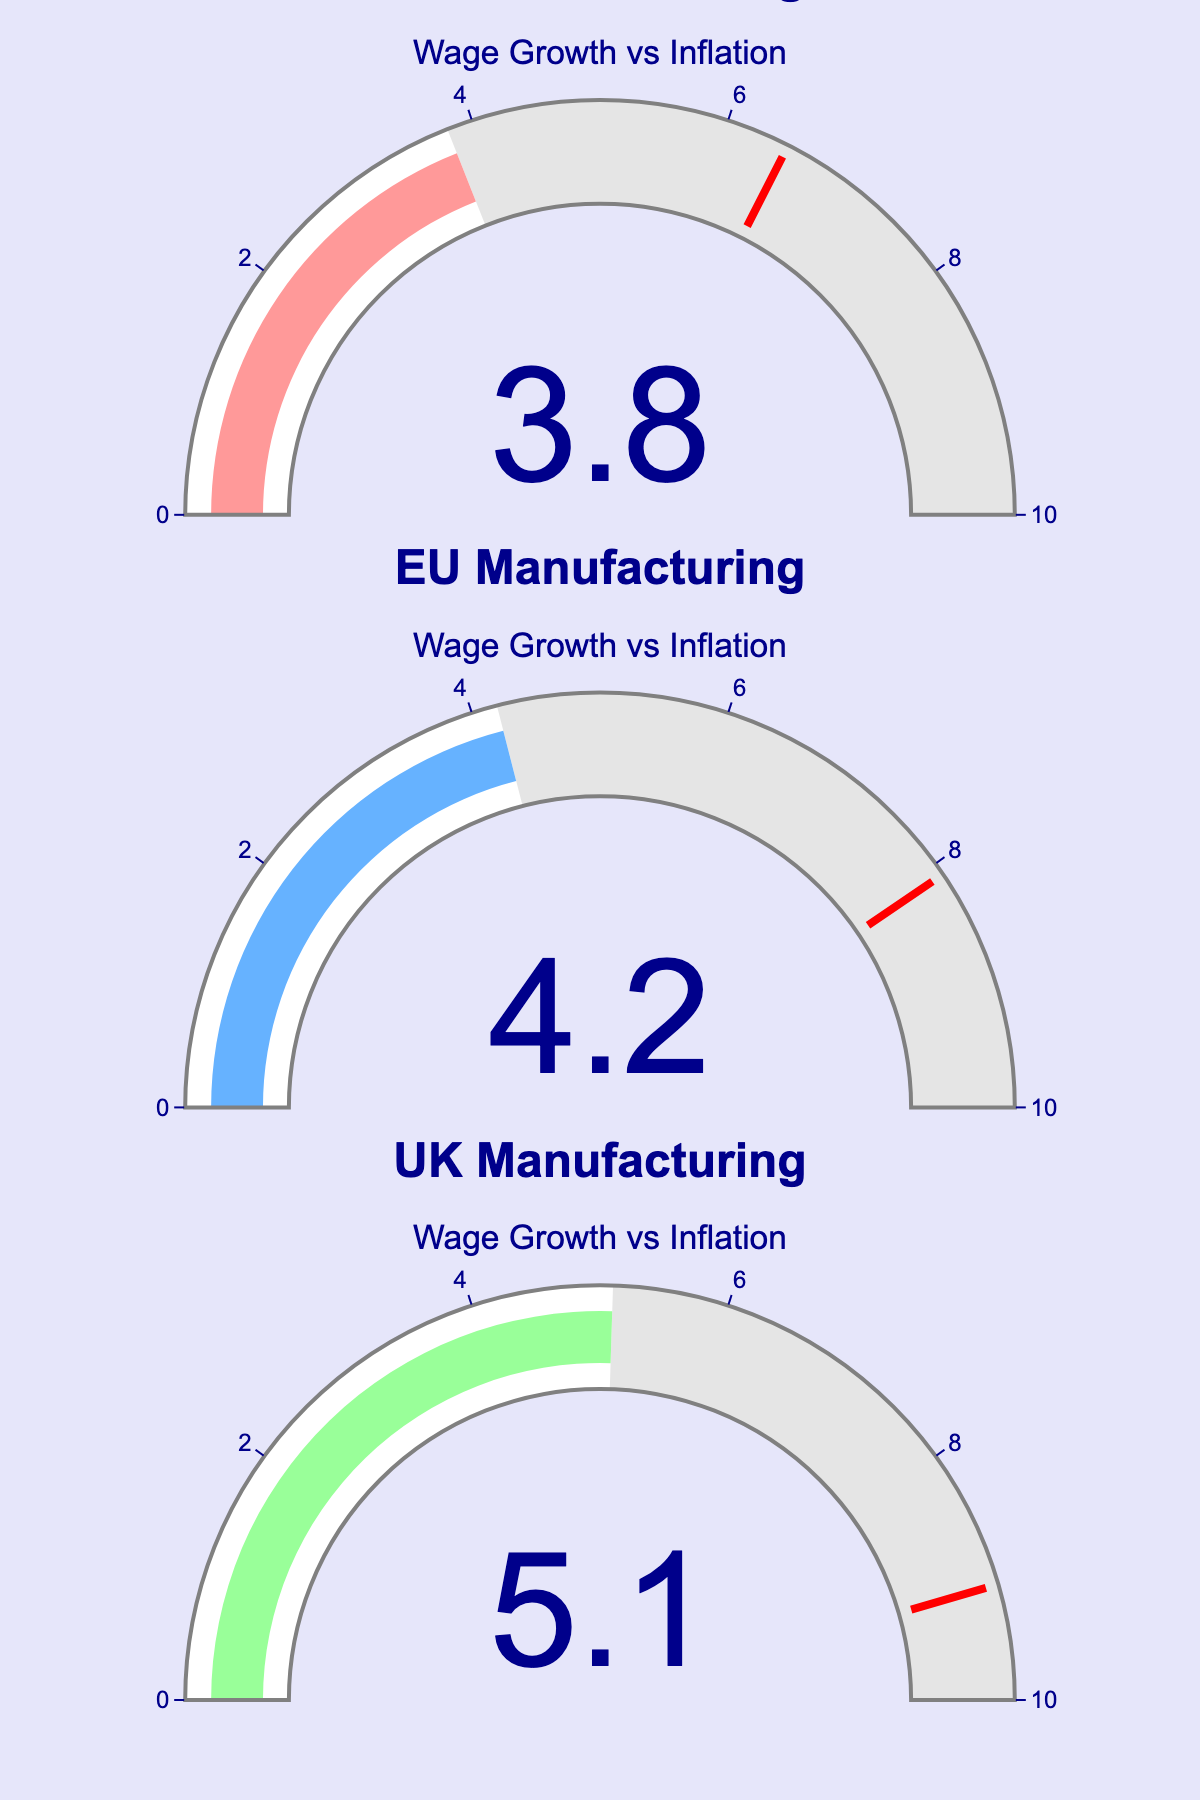What is the wage growth rate for US manufacturing in 2022? The gauge for the US manufacturing wage growth shows a value of 3.8.
Answer: 3.8 How does the inflation rate in the US compare to the manufacturing wage growth rate in 2022? The inflation rate for the US is indicated at 6.5, which is higher than the wage growth rate of 3.8.
Answer: Higher Which region has the highest manufacturing wage growth rate in 2022? The gauge for the EU manufacturing wage growth shows the highest value of 4.2, compared to the US (3.8) and the UK (5.1).
Answer: UK What is the difference between the wage growth rate and the inflation rate for the UK? The wage growth rate for the UK is 5.1 and the inflation rate is 9.1. The difference is calculated as 9.1 - 5.1 = 4.0.
Answer: 4.0 Among the US, EU, and the UK, which region has the smallest gap between wage growth and inflation in 2022? The differences between wage growth and inflation are: US (6.5 - 3.8 = 2.7), EU (8.1 - 4.2 = 3.9), and UK (9.1 - 5.1 = 4.0). The smallest gap is 2.7 (US).
Answer: US How much higher is the EU inflation rate compared to its manufacturing wage growth rate? The EU inflation rate is 8.1 while the manufacturing wage growth rate is 4.2. The difference is 8.1 - 4.2 = 3.9.
Answer: 3.9 Is the wage growth rate in the UK closer to its inflation rate compared to the US? The difference between wage growth and inflation in the UK is 4.0 (9.1 - 5.1) and in the US is 2.7 (6.5 - 3.8). Since 4.0 > 2.7, the wage growth rate in the UK is not closer to its inflation rate compared to the US.
Answer: No What overall trend can be observed about wage growth compared to inflation in all three regions? In all three regions, the inflation rate is noticeably higher than the manufacturing wage growth rate, indicating that inflation is outpacing wage growth.
Answer: Inflation outpaces wage growth 